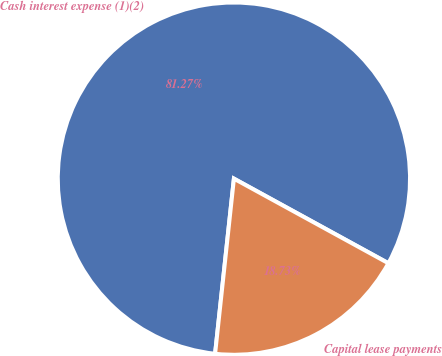<chart> <loc_0><loc_0><loc_500><loc_500><pie_chart><fcel>Cash interest expense (1)(2)<fcel>Capital lease payments<nl><fcel>81.27%<fcel>18.73%<nl></chart> 